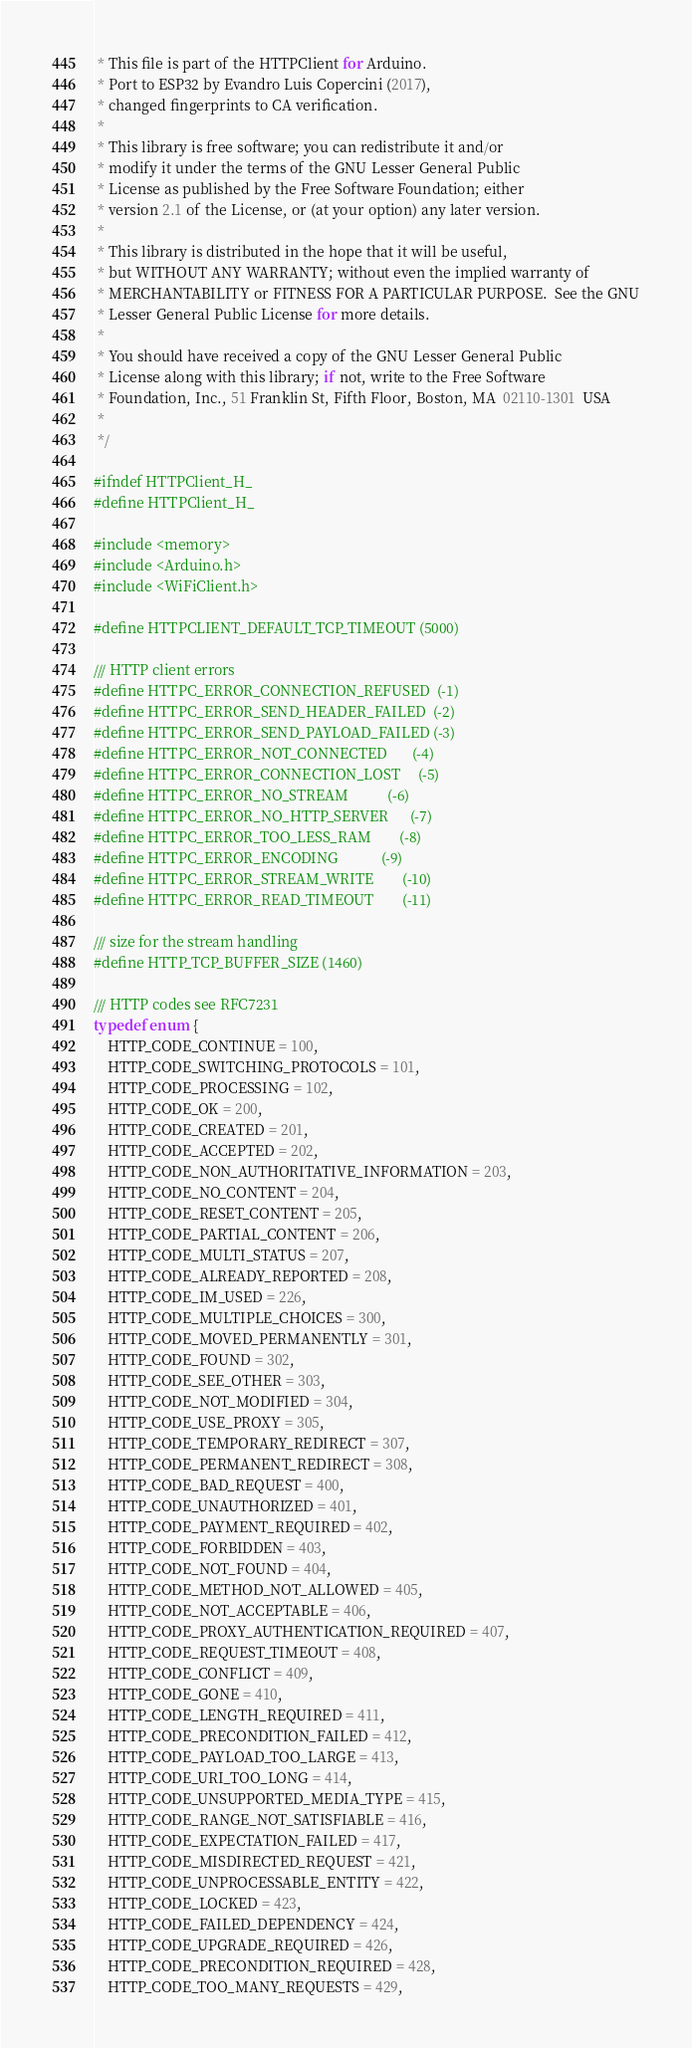Convert code to text. <code><loc_0><loc_0><loc_500><loc_500><_C_> * This file is part of the HTTPClient for Arduino.
 * Port to ESP32 by Evandro Luis Copercini (2017), 
 * changed fingerprints to CA verification. 	
 *
 * This library is free software; you can redistribute it and/or
 * modify it under the terms of the GNU Lesser General Public
 * License as published by the Free Software Foundation; either
 * version 2.1 of the License, or (at your option) any later version.
 *
 * This library is distributed in the hope that it will be useful,
 * but WITHOUT ANY WARRANTY; without even the implied warranty of
 * MERCHANTABILITY or FITNESS FOR A PARTICULAR PURPOSE.  See the GNU
 * Lesser General Public License for more details.
 *
 * You should have received a copy of the GNU Lesser General Public
 * License along with this library; if not, write to the Free Software
 * Foundation, Inc., 51 Franklin St, Fifth Floor, Boston, MA  02110-1301  USA
 *
 */

#ifndef HTTPClient_H_
#define HTTPClient_H_

#include <memory>
#include <Arduino.h>
#include <WiFiClient.h>

#define HTTPCLIENT_DEFAULT_TCP_TIMEOUT (5000)

/// HTTP client errors
#define HTTPC_ERROR_CONNECTION_REFUSED  (-1)
#define HTTPC_ERROR_SEND_HEADER_FAILED  (-2)
#define HTTPC_ERROR_SEND_PAYLOAD_FAILED (-3)
#define HTTPC_ERROR_NOT_CONNECTED       (-4)
#define HTTPC_ERROR_CONNECTION_LOST     (-5)
#define HTTPC_ERROR_NO_STREAM           (-6)
#define HTTPC_ERROR_NO_HTTP_SERVER      (-7)
#define HTTPC_ERROR_TOO_LESS_RAM        (-8)
#define HTTPC_ERROR_ENCODING            (-9)
#define HTTPC_ERROR_STREAM_WRITE        (-10)
#define HTTPC_ERROR_READ_TIMEOUT        (-11)

/// size for the stream handling
#define HTTP_TCP_BUFFER_SIZE (1460)

/// HTTP codes see RFC7231
typedef enum {
    HTTP_CODE_CONTINUE = 100,
    HTTP_CODE_SWITCHING_PROTOCOLS = 101,
    HTTP_CODE_PROCESSING = 102,
    HTTP_CODE_OK = 200,
    HTTP_CODE_CREATED = 201,
    HTTP_CODE_ACCEPTED = 202,
    HTTP_CODE_NON_AUTHORITATIVE_INFORMATION = 203,
    HTTP_CODE_NO_CONTENT = 204,
    HTTP_CODE_RESET_CONTENT = 205,
    HTTP_CODE_PARTIAL_CONTENT = 206,
    HTTP_CODE_MULTI_STATUS = 207,
    HTTP_CODE_ALREADY_REPORTED = 208,
    HTTP_CODE_IM_USED = 226,
    HTTP_CODE_MULTIPLE_CHOICES = 300,
    HTTP_CODE_MOVED_PERMANENTLY = 301,
    HTTP_CODE_FOUND = 302,
    HTTP_CODE_SEE_OTHER = 303,
    HTTP_CODE_NOT_MODIFIED = 304,
    HTTP_CODE_USE_PROXY = 305,
    HTTP_CODE_TEMPORARY_REDIRECT = 307,
    HTTP_CODE_PERMANENT_REDIRECT = 308,
    HTTP_CODE_BAD_REQUEST = 400,
    HTTP_CODE_UNAUTHORIZED = 401,
    HTTP_CODE_PAYMENT_REQUIRED = 402,
    HTTP_CODE_FORBIDDEN = 403,
    HTTP_CODE_NOT_FOUND = 404,
    HTTP_CODE_METHOD_NOT_ALLOWED = 405,
    HTTP_CODE_NOT_ACCEPTABLE = 406,
    HTTP_CODE_PROXY_AUTHENTICATION_REQUIRED = 407,
    HTTP_CODE_REQUEST_TIMEOUT = 408,
    HTTP_CODE_CONFLICT = 409,
    HTTP_CODE_GONE = 410,
    HTTP_CODE_LENGTH_REQUIRED = 411,
    HTTP_CODE_PRECONDITION_FAILED = 412,
    HTTP_CODE_PAYLOAD_TOO_LARGE = 413,
    HTTP_CODE_URI_TOO_LONG = 414,
    HTTP_CODE_UNSUPPORTED_MEDIA_TYPE = 415,
    HTTP_CODE_RANGE_NOT_SATISFIABLE = 416,
    HTTP_CODE_EXPECTATION_FAILED = 417,
    HTTP_CODE_MISDIRECTED_REQUEST = 421,
    HTTP_CODE_UNPROCESSABLE_ENTITY = 422,
    HTTP_CODE_LOCKED = 423,
    HTTP_CODE_FAILED_DEPENDENCY = 424,
    HTTP_CODE_UPGRADE_REQUIRED = 426,
    HTTP_CODE_PRECONDITION_REQUIRED = 428,
    HTTP_CODE_TOO_MANY_REQUESTS = 429,</code> 